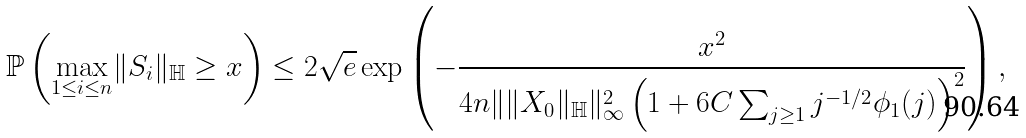Convert formula to latex. <formula><loc_0><loc_0><loc_500><loc_500>\mathbb { P } \left ( \underset { 1 \leq i \leq n } { \max } \| S _ { i } \| _ { \mathbb { H } } \geq x \right ) \leq 2 \sqrt { e } \exp \left ( - \frac { x ^ { 2 } } { 4 n \| \| X _ { 0 } \| _ { \mathbb { H } } \| ^ { 2 } _ { \infty } \left ( 1 + 6 C \sum _ { j \geq 1 } j ^ { - 1 / 2 } \phi _ { 1 } ( j ) \right ) ^ { 2 } } \right ) ,</formula> 